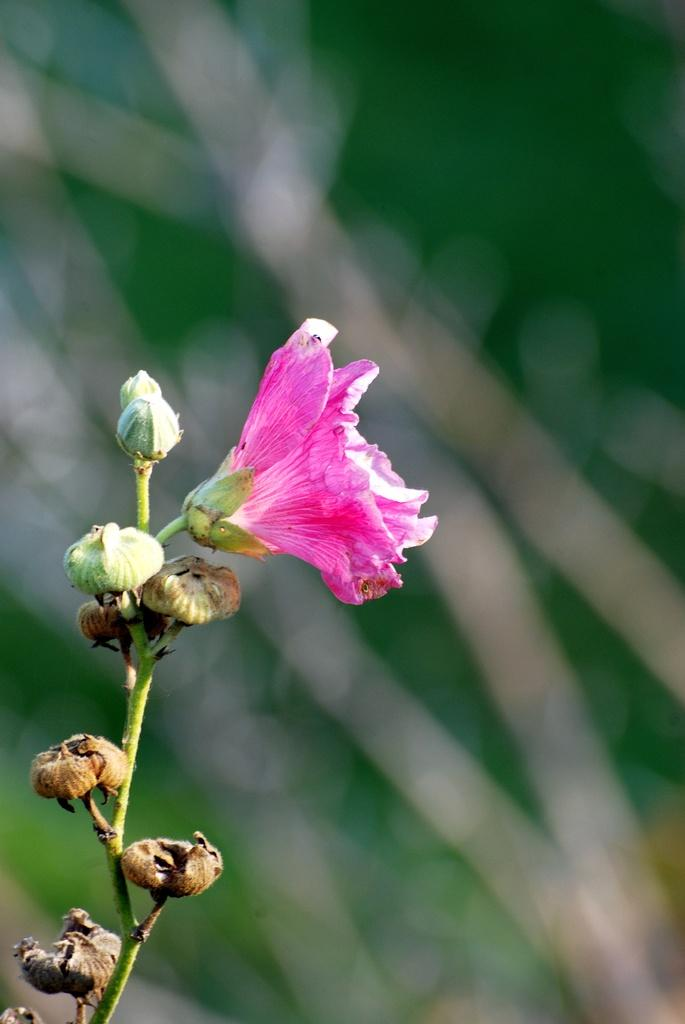What type of flower can be seen in the image? There is a pink color flower in the image. Are there any unopened flowers on the plant in the image? Yes, there are buds on the plant in the image. Can you describe the background of the image? The background of the image is blurry. What type of cheese is wrapped in the parcel in the image? There is no cheese or parcel present in the image; it features a pink color flower and a plant with buds. Can you see the coastline in the background of the image? There is no coastline visible in the image; the background is blurry. 